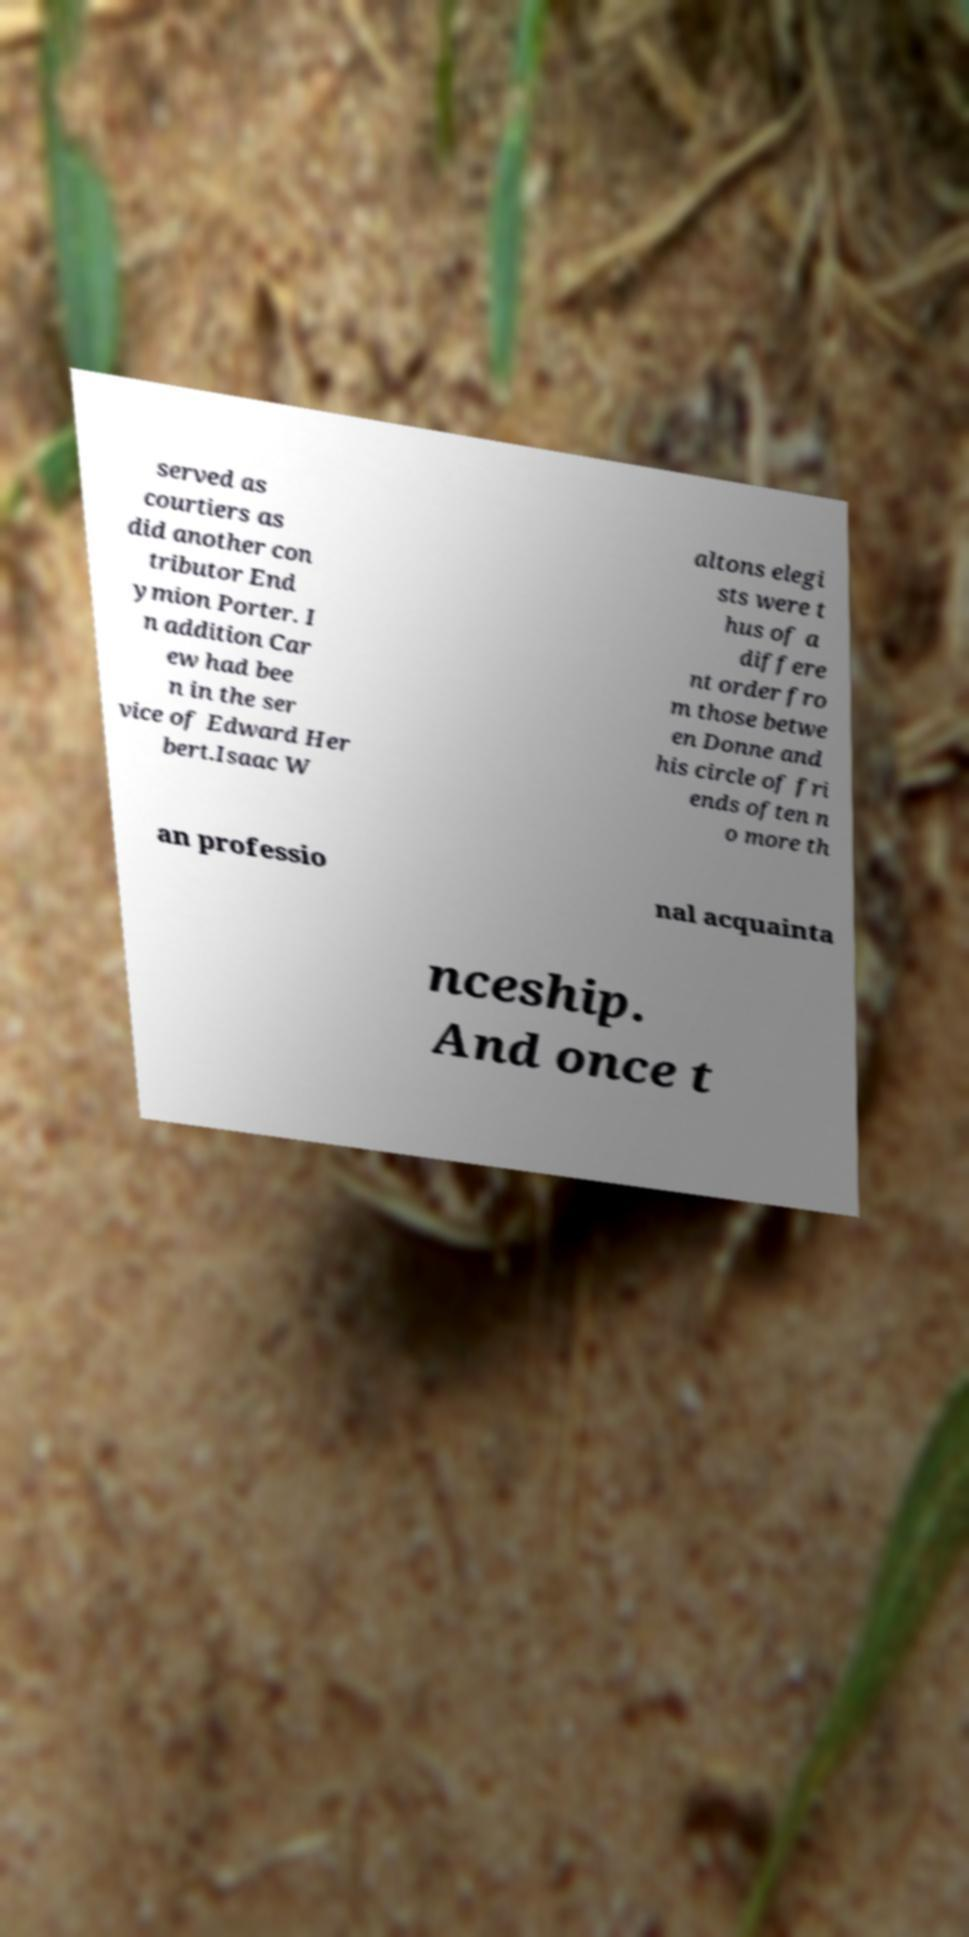Can you read and provide the text displayed in the image?This photo seems to have some interesting text. Can you extract and type it out for me? served as courtiers as did another con tributor End ymion Porter. I n addition Car ew had bee n in the ser vice of Edward Her bert.Isaac W altons elegi sts were t hus of a differe nt order fro m those betwe en Donne and his circle of fri ends often n o more th an professio nal acquainta nceship. And once t 